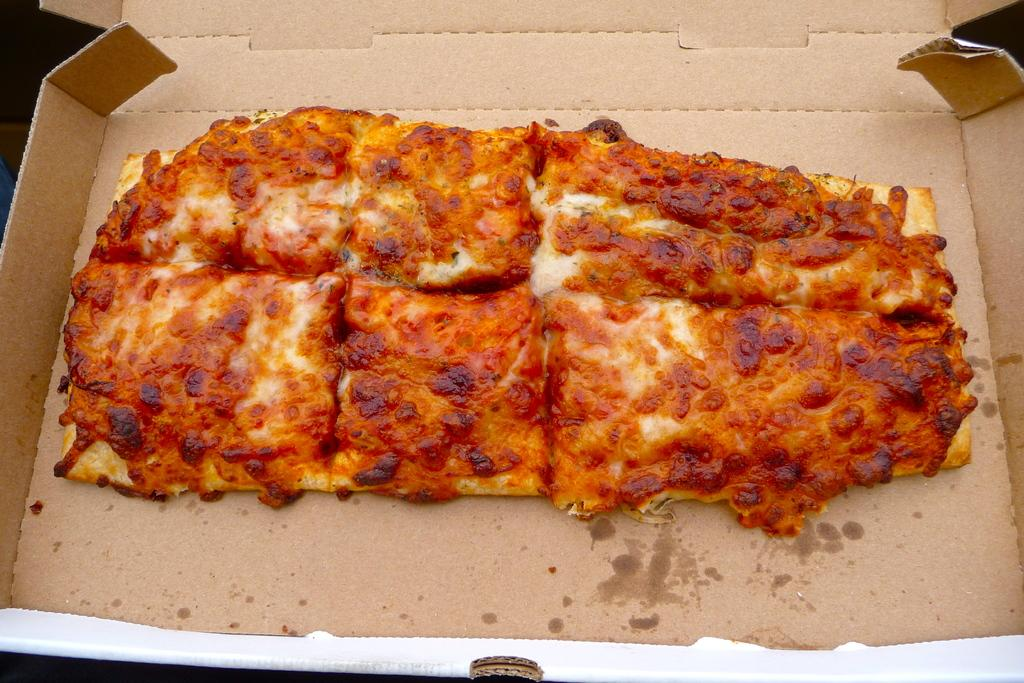What is the main object in the image? There is a pizza box in the image. What is inside the pizza box? The pizza box contains pizza pieces. What type of drug can be seen in the image? There is no drug present in the image; it is a pizza box containing pizza pieces. 